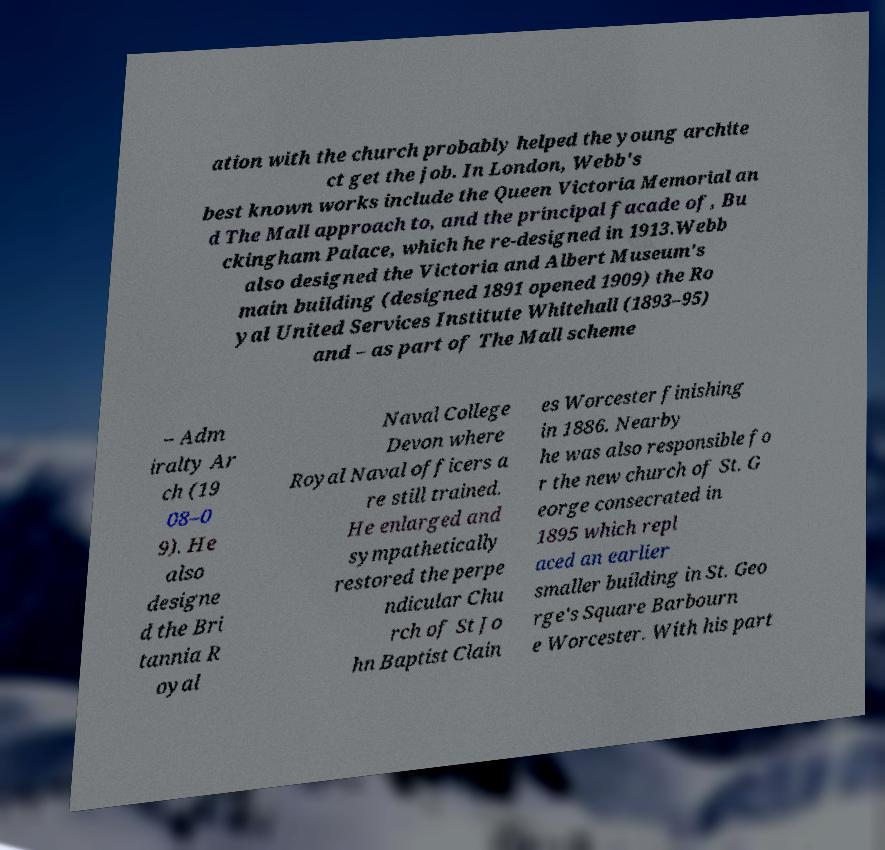Can you accurately transcribe the text from the provided image for me? ation with the church probably helped the young archite ct get the job. In London, Webb's best known works include the Queen Victoria Memorial an d The Mall approach to, and the principal facade of, Bu ckingham Palace, which he re-designed in 1913.Webb also designed the Victoria and Albert Museum's main building (designed 1891 opened 1909) the Ro yal United Services Institute Whitehall (1893–95) and – as part of The Mall scheme – Adm iralty Ar ch (19 08–0 9). He also designe d the Bri tannia R oyal Naval College Devon where Royal Naval officers a re still trained. He enlarged and sympathetically restored the perpe ndicular Chu rch of St Jo hn Baptist Clain es Worcester finishing in 1886. Nearby he was also responsible fo r the new church of St. G eorge consecrated in 1895 which repl aced an earlier smaller building in St. Geo rge's Square Barbourn e Worcester. With his part 